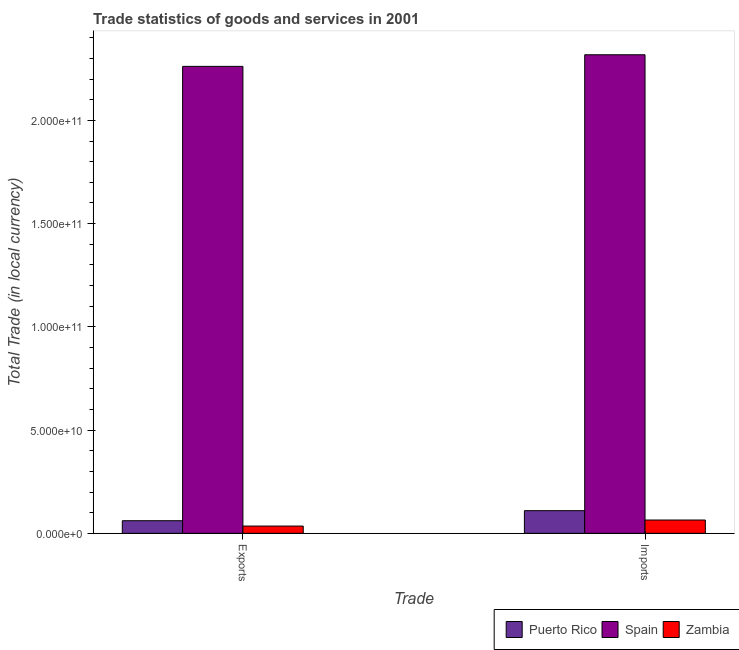Are the number of bars per tick equal to the number of legend labels?
Your response must be concise. Yes. Are the number of bars on each tick of the X-axis equal?
Your answer should be very brief. Yes. What is the label of the 1st group of bars from the left?
Offer a very short reply. Exports. What is the imports of goods and services in Spain?
Your answer should be compact. 2.32e+11. Across all countries, what is the maximum imports of goods and services?
Your answer should be compact. 2.32e+11. Across all countries, what is the minimum imports of goods and services?
Provide a succinct answer. 6.44e+09. In which country was the export of goods and services minimum?
Ensure brevity in your answer.  Zambia. What is the total export of goods and services in the graph?
Your response must be concise. 2.36e+11. What is the difference between the export of goods and services in Zambia and that in Spain?
Keep it short and to the point. -2.23e+11. What is the difference between the imports of goods and services in Zambia and the export of goods and services in Puerto Rico?
Provide a succinct answer. 3.28e+08. What is the average export of goods and services per country?
Your response must be concise. 7.86e+1. What is the difference between the imports of goods and services and export of goods and services in Zambia?
Offer a very short reply. 2.92e+09. In how many countries, is the imports of goods and services greater than 70000000000 LCU?
Offer a terse response. 1. What is the ratio of the imports of goods and services in Spain to that in Zambia?
Your answer should be compact. 35.98. What does the 3rd bar from the left in Exports represents?
Ensure brevity in your answer.  Zambia. What does the 2nd bar from the right in Exports represents?
Provide a short and direct response. Spain. Are all the bars in the graph horizontal?
Offer a terse response. No. How many countries are there in the graph?
Keep it short and to the point. 3. Are the values on the major ticks of Y-axis written in scientific E-notation?
Your answer should be compact. Yes. Does the graph contain grids?
Your answer should be very brief. No. Where does the legend appear in the graph?
Your answer should be compact. Bottom right. What is the title of the graph?
Your answer should be very brief. Trade statistics of goods and services in 2001. Does "Solomon Islands" appear as one of the legend labels in the graph?
Keep it short and to the point. No. What is the label or title of the X-axis?
Provide a short and direct response. Trade. What is the label or title of the Y-axis?
Your answer should be very brief. Total Trade (in local currency). What is the Total Trade (in local currency) in Puerto Rico in Exports?
Offer a very short reply. 6.11e+09. What is the Total Trade (in local currency) of Spain in Exports?
Your answer should be very brief. 2.26e+11. What is the Total Trade (in local currency) in Zambia in Exports?
Your answer should be compact. 3.53e+09. What is the Total Trade (in local currency) in Puerto Rico in Imports?
Provide a succinct answer. 1.10e+1. What is the Total Trade (in local currency) of Spain in Imports?
Your answer should be very brief. 2.32e+11. What is the Total Trade (in local currency) of Zambia in Imports?
Make the answer very short. 6.44e+09. Across all Trade, what is the maximum Total Trade (in local currency) in Puerto Rico?
Provide a short and direct response. 1.10e+1. Across all Trade, what is the maximum Total Trade (in local currency) of Spain?
Ensure brevity in your answer.  2.32e+11. Across all Trade, what is the maximum Total Trade (in local currency) in Zambia?
Give a very brief answer. 6.44e+09. Across all Trade, what is the minimum Total Trade (in local currency) in Puerto Rico?
Ensure brevity in your answer.  6.11e+09. Across all Trade, what is the minimum Total Trade (in local currency) of Spain?
Ensure brevity in your answer.  2.26e+11. Across all Trade, what is the minimum Total Trade (in local currency) of Zambia?
Offer a very short reply. 3.53e+09. What is the total Total Trade (in local currency) in Puerto Rico in the graph?
Ensure brevity in your answer.  1.71e+1. What is the total Total Trade (in local currency) of Spain in the graph?
Provide a succinct answer. 4.58e+11. What is the total Total Trade (in local currency) of Zambia in the graph?
Ensure brevity in your answer.  9.97e+09. What is the difference between the Total Trade (in local currency) in Puerto Rico in Exports and that in Imports?
Provide a short and direct response. -4.86e+09. What is the difference between the Total Trade (in local currency) of Spain in Exports and that in Imports?
Your answer should be very brief. -5.62e+09. What is the difference between the Total Trade (in local currency) of Zambia in Exports and that in Imports?
Ensure brevity in your answer.  -2.92e+09. What is the difference between the Total Trade (in local currency) of Puerto Rico in Exports and the Total Trade (in local currency) of Spain in Imports?
Ensure brevity in your answer.  -2.26e+11. What is the difference between the Total Trade (in local currency) of Puerto Rico in Exports and the Total Trade (in local currency) of Zambia in Imports?
Make the answer very short. -3.28e+08. What is the difference between the Total Trade (in local currency) in Spain in Exports and the Total Trade (in local currency) in Zambia in Imports?
Make the answer very short. 2.20e+11. What is the average Total Trade (in local currency) of Puerto Rico per Trade?
Make the answer very short. 8.54e+09. What is the average Total Trade (in local currency) in Spain per Trade?
Give a very brief answer. 2.29e+11. What is the average Total Trade (in local currency) in Zambia per Trade?
Your answer should be very brief. 4.98e+09. What is the difference between the Total Trade (in local currency) in Puerto Rico and Total Trade (in local currency) in Spain in Exports?
Your answer should be compact. -2.20e+11. What is the difference between the Total Trade (in local currency) of Puerto Rico and Total Trade (in local currency) of Zambia in Exports?
Offer a very short reply. 2.59e+09. What is the difference between the Total Trade (in local currency) of Spain and Total Trade (in local currency) of Zambia in Exports?
Offer a terse response. 2.23e+11. What is the difference between the Total Trade (in local currency) of Puerto Rico and Total Trade (in local currency) of Spain in Imports?
Ensure brevity in your answer.  -2.21e+11. What is the difference between the Total Trade (in local currency) in Puerto Rico and Total Trade (in local currency) in Zambia in Imports?
Give a very brief answer. 4.53e+09. What is the difference between the Total Trade (in local currency) in Spain and Total Trade (in local currency) in Zambia in Imports?
Keep it short and to the point. 2.25e+11. What is the ratio of the Total Trade (in local currency) in Puerto Rico in Exports to that in Imports?
Give a very brief answer. 0.56. What is the ratio of the Total Trade (in local currency) in Spain in Exports to that in Imports?
Your response must be concise. 0.98. What is the ratio of the Total Trade (in local currency) in Zambia in Exports to that in Imports?
Your response must be concise. 0.55. What is the difference between the highest and the second highest Total Trade (in local currency) in Puerto Rico?
Your answer should be compact. 4.86e+09. What is the difference between the highest and the second highest Total Trade (in local currency) in Spain?
Offer a very short reply. 5.62e+09. What is the difference between the highest and the second highest Total Trade (in local currency) of Zambia?
Keep it short and to the point. 2.92e+09. What is the difference between the highest and the lowest Total Trade (in local currency) in Puerto Rico?
Your answer should be compact. 4.86e+09. What is the difference between the highest and the lowest Total Trade (in local currency) in Spain?
Provide a succinct answer. 5.62e+09. What is the difference between the highest and the lowest Total Trade (in local currency) of Zambia?
Your response must be concise. 2.92e+09. 